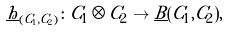Convert formula to latex. <formula><loc_0><loc_0><loc_500><loc_500>\underline { h } _ { ( C _ { 1 } , C _ { 2 } ) } \colon C _ { 1 } \otimes C _ { 2 } \to \underline { B } ( C _ { 1 } , C _ { 2 } ) ,</formula> 